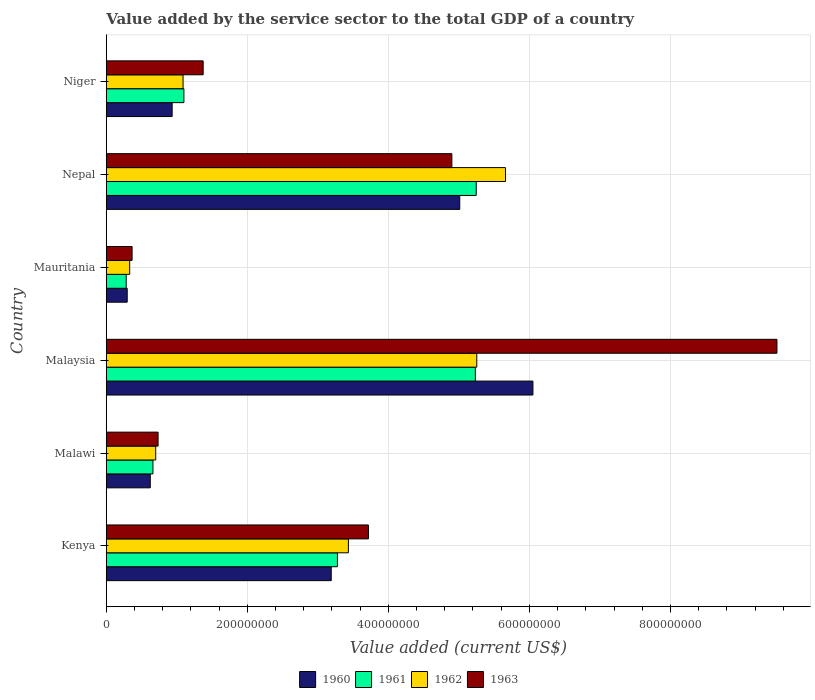How many different coloured bars are there?
Your answer should be compact. 4. How many bars are there on the 6th tick from the bottom?
Your answer should be very brief. 4. What is the label of the 6th group of bars from the top?
Ensure brevity in your answer.  Kenya. In how many cases, is the number of bars for a given country not equal to the number of legend labels?
Offer a terse response. 0. What is the value added by the service sector to the total GDP in 1961 in Nepal?
Provide a succinct answer. 5.25e+08. Across all countries, what is the maximum value added by the service sector to the total GDP in 1961?
Keep it short and to the point. 5.25e+08. Across all countries, what is the minimum value added by the service sector to the total GDP in 1960?
Your answer should be compact. 2.97e+07. In which country was the value added by the service sector to the total GDP in 1961 maximum?
Make the answer very short. Nepal. In which country was the value added by the service sector to the total GDP in 1960 minimum?
Your response must be concise. Mauritania. What is the total value added by the service sector to the total GDP in 1960 in the graph?
Give a very brief answer. 1.61e+09. What is the difference between the value added by the service sector to the total GDP in 1960 in Kenya and that in Nepal?
Make the answer very short. -1.82e+08. What is the difference between the value added by the service sector to the total GDP in 1960 in Malaysia and the value added by the service sector to the total GDP in 1962 in Niger?
Keep it short and to the point. 4.96e+08. What is the average value added by the service sector to the total GDP in 1962 per country?
Your answer should be very brief. 2.75e+08. What is the difference between the value added by the service sector to the total GDP in 1960 and value added by the service sector to the total GDP in 1962 in Kenya?
Ensure brevity in your answer.  -2.43e+07. What is the ratio of the value added by the service sector to the total GDP in 1962 in Kenya to that in Malaysia?
Your response must be concise. 0.65. Is the value added by the service sector to the total GDP in 1963 in Nepal less than that in Niger?
Keep it short and to the point. No. Is the difference between the value added by the service sector to the total GDP in 1960 in Kenya and Nepal greater than the difference between the value added by the service sector to the total GDP in 1962 in Kenya and Nepal?
Provide a succinct answer. Yes. What is the difference between the highest and the second highest value added by the service sector to the total GDP in 1963?
Keep it short and to the point. 4.61e+08. What is the difference between the highest and the lowest value added by the service sector to the total GDP in 1962?
Give a very brief answer. 5.33e+08. What does the 4th bar from the top in Niger represents?
Keep it short and to the point. 1960. What does the 4th bar from the bottom in Malawi represents?
Your answer should be very brief. 1963. Are all the bars in the graph horizontal?
Give a very brief answer. Yes. How many countries are there in the graph?
Your answer should be very brief. 6. What is the difference between two consecutive major ticks on the X-axis?
Offer a very short reply. 2.00e+08. Are the values on the major ticks of X-axis written in scientific E-notation?
Keep it short and to the point. No. Does the graph contain grids?
Offer a terse response. Yes. How are the legend labels stacked?
Keep it short and to the point. Horizontal. What is the title of the graph?
Provide a short and direct response. Value added by the service sector to the total GDP of a country. Does "2011" appear as one of the legend labels in the graph?
Your response must be concise. No. What is the label or title of the X-axis?
Provide a succinct answer. Value added (current US$). What is the Value added (current US$) of 1960 in Kenya?
Make the answer very short. 3.19e+08. What is the Value added (current US$) of 1961 in Kenya?
Offer a terse response. 3.28e+08. What is the Value added (current US$) in 1962 in Kenya?
Ensure brevity in your answer.  3.43e+08. What is the Value added (current US$) in 1963 in Kenya?
Your response must be concise. 3.72e+08. What is the Value added (current US$) in 1960 in Malawi?
Offer a very short reply. 6.24e+07. What is the Value added (current US$) of 1961 in Malawi?
Ensure brevity in your answer.  6.62e+07. What is the Value added (current US$) in 1962 in Malawi?
Your answer should be very brief. 7.01e+07. What is the Value added (current US$) in 1963 in Malawi?
Keep it short and to the point. 7.35e+07. What is the Value added (current US$) of 1960 in Malaysia?
Ensure brevity in your answer.  6.05e+08. What is the Value added (current US$) of 1961 in Malaysia?
Offer a terse response. 5.23e+08. What is the Value added (current US$) in 1962 in Malaysia?
Your answer should be very brief. 5.25e+08. What is the Value added (current US$) of 1963 in Malaysia?
Make the answer very short. 9.51e+08. What is the Value added (current US$) of 1960 in Mauritania?
Your response must be concise. 2.97e+07. What is the Value added (current US$) in 1961 in Mauritania?
Your answer should be compact. 2.83e+07. What is the Value added (current US$) in 1962 in Mauritania?
Provide a succinct answer. 3.32e+07. What is the Value added (current US$) of 1963 in Mauritania?
Make the answer very short. 3.67e+07. What is the Value added (current US$) in 1960 in Nepal?
Your response must be concise. 5.01e+08. What is the Value added (current US$) in 1961 in Nepal?
Provide a succinct answer. 5.25e+08. What is the Value added (current US$) of 1962 in Nepal?
Give a very brief answer. 5.66e+08. What is the Value added (current US$) in 1963 in Nepal?
Your answer should be compact. 4.90e+08. What is the Value added (current US$) in 1960 in Niger?
Provide a short and direct response. 9.35e+07. What is the Value added (current US$) in 1961 in Niger?
Your response must be concise. 1.10e+08. What is the Value added (current US$) in 1962 in Niger?
Offer a terse response. 1.09e+08. What is the Value added (current US$) of 1963 in Niger?
Offer a terse response. 1.37e+08. Across all countries, what is the maximum Value added (current US$) in 1960?
Ensure brevity in your answer.  6.05e+08. Across all countries, what is the maximum Value added (current US$) of 1961?
Your answer should be very brief. 5.25e+08. Across all countries, what is the maximum Value added (current US$) of 1962?
Your answer should be compact. 5.66e+08. Across all countries, what is the maximum Value added (current US$) of 1963?
Give a very brief answer. 9.51e+08. Across all countries, what is the minimum Value added (current US$) in 1960?
Your answer should be very brief. 2.97e+07. Across all countries, what is the minimum Value added (current US$) of 1961?
Offer a very short reply. 2.83e+07. Across all countries, what is the minimum Value added (current US$) of 1962?
Your answer should be compact. 3.32e+07. Across all countries, what is the minimum Value added (current US$) of 1963?
Ensure brevity in your answer.  3.67e+07. What is the total Value added (current US$) in 1960 in the graph?
Make the answer very short. 1.61e+09. What is the total Value added (current US$) in 1961 in the graph?
Offer a very short reply. 1.58e+09. What is the total Value added (current US$) of 1962 in the graph?
Offer a very short reply. 1.65e+09. What is the total Value added (current US$) of 1963 in the graph?
Your response must be concise. 2.06e+09. What is the difference between the Value added (current US$) of 1960 in Kenya and that in Malawi?
Your answer should be very brief. 2.57e+08. What is the difference between the Value added (current US$) in 1961 in Kenya and that in Malawi?
Give a very brief answer. 2.62e+08. What is the difference between the Value added (current US$) in 1962 in Kenya and that in Malawi?
Your answer should be compact. 2.73e+08. What is the difference between the Value added (current US$) in 1963 in Kenya and that in Malawi?
Ensure brevity in your answer.  2.98e+08. What is the difference between the Value added (current US$) in 1960 in Kenya and that in Malaysia?
Provide a short and direct response. -2.86e+08. What is the difference between the Value added (current US$) of 1961 in Kenya and that in Malaysia?
Offer a very short reply. -1.96e+08. What is the difference between the Value added (current US$) of 1962 in Kenya and that in Malaysia?
Provide a short and direct response. -1.82e+08. What is the difference between the Value added (current US$) in 1963 in Kenya and that in Malaysia?
Give a very brief answer. -5.79e+08. What is the difference between the Value added (current US$) of 1960 in Kenya and that in Mauritania?
Offer a terse response. 2.89e+08. What is the difference between the Value added (current US$) of 1961 in Kenya and that in Mauritania?
Give a very brief answer. 3.00e+08. What is the difference between the Value added (current US$) in 1962 in Kenya and that in Mauritania?
Offer a terse response. 3.10e+08. What is the difference between the Value added (current US$) in 1963 in Kenya and that in Mauritania?
Ensure brevity in your answer.  3.35e+08. What is the difference between the Value added (current US$) of 1960 in Kenya and that in Nepal?
Keep it short and to the point. -1.82e+08. What is the difference between the Value added (current US$) of 1961 in Kenya and that in Nepal?
Your answer should be very brief. -1.97e+08. What is the difference between the Value added (current US$) in 1962 in Kenya and that in Nepal?
Your answer should be very brief. -2.23e+08. What is the difference between the Value added (current US$) of 1963 in Kenya and that in Nepal?
Your answer should be very brief. -1.18e+08. What is the difference between the Value added (current US$) of 1960 in Kenya and that in Niger?
Keep it short and to the point. 2.26e+08. What is the difference between the Value added (current US$) of 1961 in Kenya and that in Niger?
Keep it short and to the point. 2.18e+08. What is the difference between the Value added (current US$) in 1962 in Kenya and that in Niger?
Keep it short and to the point. 2.34e+08. What is the difference between the Value added (current US$) in 1963 in Kenya and that in Niger?
Provide a short and direct response. 2.34e+08. What is the difference between the Value added (current US$) of 1960 in Malawi and that in Malaysia?
Keep it short and to the point. -5.43e+08. What is the difference between the Value added (current US$) of 1961 in Malawi and that in Malaysia?
Provide a succinct answer. -4.57e+08. What is the difference between the Value added (current US$) in 1962 in Malawi and that in Malaysia?
Give a very brief answer. -4.55e+08. What is the difference between the Value added (current US$) in 1963 in Malawi and that in Malaysia?
Provide a succinct answer. -8.78e+08. What is the difference between the Value added (current US$) in 1960 in Malawi and that in Mauritania?
Make the answer very short. 3.27e+07. What is the difference between the Value added (current US$) of 1961 in Malawi and that in Mauritania?
Offer a terse response. 3.79e+07. What is the difference between the Value added (current US$) of 1962 in Malawi and that in Mauritania?
Provide a succinct answer. 3.69e+07. What is the difference between the Value added (current US$) in 1963 in Malawi and that in Mauritania?
Ensure brevity in your answer.  3.68e+07. What is the difference between the Value added (current US$) in 1960 in Malawi and that in Nepal?
Ensure brevity in your answer.  -4.39e+08. What is the difference between the Value added (current US$) in 1961 in Malawi and that in Nepal?
Provide a succinct answer. -4.58e+08. What is the difference between the Value added (current US$) in 1962 in Malawi and that in Nepal?
Your answer should be compact. -4.96e+08. What is the difference between the Value added (current US$) in 1963 in Malawi and that in Nepal?
Make the answer very short. -4.17e+08. What is the difference between the Value added (current US$) in 1960 in Malawi and that in Niger?
Your answer should be compact. -3.10e+07. What is the difference between the Value added (current US$) of 1961 in Malawi and that in Niger?
Your response must be concise. -4.39e+07. What is the difference between the Value added (current US$) in 1962 in Malawi and that in Niger?
Keep it short and to the point. -3.88e+07. What is the difference between the Value added (current US$) in 1963 in Malawi and that in Niger?
Your answer should be very brief. -6.39e+07. What is the difference between the Value added (current US$) of 1960 in Malaysia and that in Mauritania?
Make the answer very short. 5.75e+08. What is the difference between the Value added (current US$) in 1961 in Malaysia and that in Mauritania?
Make the answer very short. 4.95e+08. What is the difference between the Value added (current US$) of 1962 in Malaysia and that in Mauritania?
Provide a succinct answer. 4.92e+08. What is the difference between the Value added (current US$) of 1963 in Malaysia and that in Mauritania?
Ensure brevity in your answer.  9.14e+08. What is the difference between the Value added (current US$) of 1960 in Malaysia and that in Nepal?
Offer a very short reply. 1.04e+08. What is the difference between the Value added (current US$) in 1961 in Malaysia and that in Nepal?
Offer a very short reply. -1.26e+06. What is the difference between the Value added (current US$) in 1962 in Malaysia and that in Nepal?
Your answer should be compact. -4.07e+07. What is the difference between the Value added (current US$) in 1963 in Malaysia and that in Nepal?
Keep it short and to the point. 4.61e+08. What is the difference between the Value added (current US$) in 1960 in Malaysia and that in Niger?
Your answer should be very brief. 5.12e+08. What is the difference between the Value added (current US$) in 1961 in Malaysia and that in Niger?
Offer a terse response. 4.13e+08. What is the difference between the Value added (current US$) in 1962 in Malaysia and that in Niger?
Provide a short and direct response. 4.16e+08. What is the difference between the Value added (current US$) in 1963 in Malaysia and that in Niger?
Offer a terse response. 8.14e+08. What is the difference between the Value added (current US$) of 1960 in Mauritania and that in Nepal?
Your answer should be very brief. -4.72e+08. What is the difference between the Value added (current US$) of 1961 in Mauritania and that in Nepal?
Ensure brevity in your answer.  -4.96e+08. What is the difference between the Value added (current US$) in 1962 in Mauritania and that in Nepal?
Keep it short and to the point. -5.33e+08. What is the difference between the Value added (current US$) of 1963 in Mauritania and that in Nepal?
Offer a very short reply. -4.53e+08. What is the difference between the Value added (current US$) in 1960 in Mauritania and that in Niger?
Keep it short and to the point. -6.37e+07. What is the difference between the Value added (current US$) of 1961 in Mauritania and that in Niger?
Ensure brevity in your answer.  -8.18e+07. What is the difference between the Value added (current US$) in 1962 in Mauritania and that in Niger?
Your response must be concise. -7.57e+07. What is the difference between the Value added (current US$) in 1963 in Mauritania and that in Niger?
Offer a terse response. -1.01e+08. What is the difference between the Value added (current US$) in 1960 in Nepal and that in Niger?
Make the answer very short. 4.08e+08. What is the difference between the Value added (current US$) of 1961 in Nepal and that in Niger?
Your answer should be compact. 4.14e+08. What is the difference between the Value added (current US$) of 1962 in Nepal and that in Niger?
Provide a succinct answer. 4.57e+08. What is the difference between the Value added (current US$) in 1963 in Nepal and that in Niger?
Offer a very short reply. 3.53e+08. What is the difference between the Value added (current US$) of 1960 in Kenya and the Value added (current US$) of 1961 in Malawi?
Provide a succinct answer. 2.53e+08. What is the difference between the Value added (current US$) of 1960 in Kenya and the Value added (current US$) of 1962 in Malawi?
Offer a very short reply. 2.49e+08. What is the difference between the Value added (current US$) of 1960 in Kenya and the Value added (current US$) of 1963 in Malawi?
Offer a very short reply. 2.46e+08. What is the difference between the Value added (current US$) of 1961 in Kenya and the Value added (current US$) of 1962 in Malawi?
Provide a succinct answer. 2.58e+08. What is the difference between the Value added (current US$) of 1961 in Kenya and the Value added (current US$) of 1963 in Malawi?
Your answer should be very brief. 2.54e+08. What is the difference between the Value added (current US$) of 1962 in Kenya and the Value added (current US$) of 1963 in Malawi?
Offer a very short reply. 2.70e+08. What is the difference between the Value added (current US$) in 1960 in Kenya and the Value added (current US$) in 1961 in Malaysia?
Ensure brevity in your answer.  -2.04e+08. What is the difference between the Value added (current US$) of 1960 in Kenya and the Value added (current US$) of 1962 in Malaysia?
Offer a terse response. -2.06e+08. What is the difference between the Value added (current US$) in 1960 in Kenya and the Value added (current US$) in 1963 in Malaysia?
Keep it short and to the point. -6.32e+08. What is the difference between the Value added (current US$) in 1961 in Kenya and the Value added (current US$) in 1962 in Malaysia?
Keep it short and to the point. -1.98e+08. What is the difference between the Value added (current US$) of 1961 in Kenya and the Value added (current US$) of 1963 in Malaysia?
Your answer should be very brief. -6.23e+08. What is the difference between the Value added (current US$) of 1962 in Kenya and the Value added (current US$) of 1963 in Malaysia?
Offer a very short reply. -6.08e+08. What is the difference between the Value added (current US$) in 1960 in Kenya and the Value added (current US$) in 1961 in Mauritania?
Your answer should be very brief. 2.91e+08. What is the difference between the Value added (current US$) in 1960 in Kenya and the Value added (current US$) in 1962 in Mauritania?
Make the answer very short. 2.86e+08. What is the difference between the Value added (current US$) in 1960 in Kenya and the Value added (current US$) in 1963 in Mauritania?
Give a very brief answer. 2.82e+08. What is the difference between the Value added (current US$) of 1961 in Kenya and the Value added (current US$) of 1962 in Mauritania?
Provide a succinct answer. 2.95e+08. What is the difference between the Value added (current US$) in 1961 in Kenya and the Value added (current US$) in 1963 in Mauritania?
Give a very brief answer. 2.91e+08. What is the difference between the Value added (current US$) in 1962 in Kenya and the Value added (current US$) in 1963 in Mauritania?
Offer a very short reply. 3.07e+08. What is the difference between the Value added (current US$) in 1960 in Kenya and the Value added (current US$) in 1961 in Nepal?
Keep it short and to the point. -2.06e+08. What is the difference between the Value added (current US$) in 1960 in Kenya and the Value added (current US$) in 1962 in Nepal?
Ensure brevity in your answer.  -2.47e+08. What is the difference between the Value added (current US$) of 1960 in Kenya and the Value added (current US$) of 1963 in Nepal?
Offer a very short reply. -1.71e+08. What is the difference between the Value added (current US$) of 1961 in Kenya and the Value added (current US$) of 1962 in Nepal?
Give a very brief answer. -2.38e+08. What is the difference between the Value added (current US$) in 1961 in Kenya and the Value added (current US$) in 1963 in Nepal?
Your answer should be very brief. -1.62e+08. What is the difference between the Value added (current US$) in 1962 in Kenya and the Value added (current US$) in 1963 in Nepal?
Offer a very short reply. -1.47e+08. What is the difference between the Value added (current US$) of 1960 in Kenya and the Value added (current US$) of 1961 in Niger?
Provide a succinct answer. 2.09e+08. What is the difference between the Value added (current US$) in 1960 in Kenya and the Value added (current US$) in 1962 in Niger?
Your answer should be compact. 2.10e+08. What is the difference between the Value added (current US$) in 1960 in Kenya and the Value added (current US$) in 1963 in Niger?
Your answer should be compact. 1.82e+08. What is the difference between the Value added (current US$) of 1961 in Kenya and the Value added (current US$) of 1962 in Niger?
Offer a very short reply. 2.19e+08. What is the difference between the Value added (current US$) in 1961 in Kenya and the Value added (current US$) in 1963 in Niger?
Give a very brief answer. 1.90e+08. What is the difference between the Value added (current US$) in 1962 in Kenya and the Value added (current US$) in 1963 in Niger?
Provide a short and direct response. 2.06e+08. What is the difference between the Value added (current US$) of 1960 in Malawi and the Value added (current US$) of 1961 in Malaysia?
Provide a short and direct response. -4.61e+08. What is the difference between the Value added (current US$) of 1960 in Malawi and the Value added (current US$) of 1962 in Malaysia?
Give a very brief answer. -4.63e+08. What is the difference between the Value added (current US$) of 1960 in Malawi and the Value added (current US$) of 1963 in Malaysia?
Offer a very short reply. -8.89e+08. What is the difference between the Value added (current US$) of 1961 in Malawi and the Value added (current US$) of 1962 in Malaysia?
Offer a terse response. -4.59e+08. What is the difference between the Value added (current US$) of 1961 in Malawi and the Value added (current US$) of 1963 in Malaysia?
Your answer should be compact. -8.85e+08. What is the difference between the Value added (current US$) of 1962 in Malawi and the Value added (current US$) of 1963 in Malaysia?
Provide a succinct answer. -8.81e+08. What is the difference between the Value added (current US$) of 1960 in Malawi and the Value added (current US$) of 1961 in Mauritania?
Your answer should be compact. 3.41e+07. What is the difference between the Value added (current US$) of 1960 in Malawi and the Value added (current US$) of 1962 in Mauritania?
Your response must be concise. 2.92e+07. What is the difference between the Value added (current US$) of 1960 in Malawi and the Value added (current US$) of 1963 in Mauritania?
Your answer should be very brief. 2.58e+07. What is the difference between the Value added (current US$) of 1961 in Malawi and the Value added (current US$) of 1962 in Mauritania?
Offer a terse response. 3.30e+07. What is the difference between the Value added (current US$) of 1961 in Malawi and the Value added (current US$) of 1963 in Mauritania?
Give a very brief answer. 2.96e+07. What is the difference between the Value added (current US$) of 1962 in Malawi and the Value added (current US$) of 1963 in Mauritania?
Ensure brevity in your answer.  3.35e+07. What is the difference between the Value added (current US$) of 1960 in Malawi and the Value added (current US$) of 1961 in Nepal?
Ensure brevity in your answer.  -4.62e+08. What is the difference between the Value added (current US$) in 1960 in Malawi and the Value added (current US$) in 1962 in Nepal?
Make the answer very short. -5.04e+08. What is the difference between the Value added (current US$) in 1960 in Malawi and the Value added (current US$) in 1963 in Nepal?
Ensure brevity in your answer.  -4.28e+08. What is the difference between the Value added (current US$) in 1961 in Malawi and the Value added (current US$) in 1962 in Nepal?
Your response must be concise. -5.00e+08. What is the difference between the Value added (current US$) in 1961 in Malawi and the Value added (current US$) in 1963 in Nepal?
Keep it short and to the point. -4.24e+08. What is the difference between the Value added (current US$) in 1962 in Malawi and the Value added (current US$) in 1963 in Nepal?
Give a very brief answer. -4.20e+08. What is the difference between the Value added (current US$) in 1960 in Malawi and the Value added (current US$) in 1961 in Niger?
Give a very brief answer. -4.77e+07. What is the difference between the Value added (current US$) of 1960 in Malawi and the Value added (current US$) of 1962 in Niger?
Offer a terse response. -4.65e+07. What is the difference between the Value added (current US$) of 1960 in Malawi and the Value added (current US$) of 1963 in Niger?
Ensure brevity in your answer.  -7.50e+07. What is the difference between the Value added (current US$) of 1961 in Malawi and the Value added (current US$) of 1962 in Niger?
Offer a very short reply. -4.27e+07. What is the difference between the Value added (current US$) of 1961 in Malawi and the Value added (current US$) of 1963 in Niger?
Give a very brief answer. -7.12e+07. What is the difference between the Value added (current US$) in 1962 in Malawi and the Value added (current US$) in 1963 in Niger?
Your response must be concise. -6.73e+07. What is the difference between the Value added (current US$) in 1960 in Malaysia and the Value added (current US$) in 1961 in Mauritania?
Make the answer very short. 5.77e+08. What is the difference between the Value added (current US$) in 1960 in Malaysia and the Value added (current US$) in 1962 in Mauritania?
Provide a succinct answer. 5.72e+08. What is the difference between the Value added (current US$) of 1960 in Malaysia and the Value added (current US$) of 1963 in Mauritania?
Give a very brief answer. 5.68e+08. What is the difference between the Value added (current US$) of 1961 in Malaysia and the Value added (current US$) of 1962 in Mauritania?
Ensure brevity in your answer.  4.90e+08. What is the difference between the Value added (current US$) of 1961 in Malaysia and the Value added (current US$) of 1963 in Mauritania?
Provide a short and direct response. 4.87e+08. What is the difference between the Value added (current US$) in 1962 in Malaysia and the Value added (current US$) in 1963 in Mauritania?
Make the answer very short. 4.89e+08. What is the difference between the Value added (current US$) of 1960 in Malaysia and the Value added (current US$) of 1961 in Nepal?
Your answer should be very brief. 8.04e+07. What is the difference between the Value added (current US$) of 1960 in Malaysia and the Value added (current US$) of 1962 in Nepal?
Your answer should be compact. 3.89e+07. What is the difference between the Value added (current US$) in 1960 in Malaysia and the Value added (current US$) in 1963 in Nepal?
Keep it short and to the point. 1.15e+08. What is the difference between the Value added (current US$) in 1961 in Malaysia and the Value added (current US$) in 1962 in Nepal?
Give a very brief answer. -4.27e+07. What is the difference between the Value added (current US$) in 1961 in Malaysia and the Value added (current US$) in 1963 in Nepal?
Ensure brevity in your answer.  3.33e+07. What is the difference between the Value added (current US$) in 1962 in Malaysia and the Value added (current US$) in 1963 in Nepal?
Provide a succinct answer. 3.53e+07. What is the difference between the Value added (current US$) of 1960 in Malaysia and the Value added (current US$) of 1961 in Niger?
Offer a very short reply. 4.95e+08. What is the difference between the Value added (current US$) in 1960 in Malaysia and the Value added (current US$) in 1962 in Niger?
Your answer should be very brief. 4.96e+08. What is the difference between the Value added (current US$) in 1960 in Malaysia and the Value added (current US$) in 1963 in Niger?
Offer a terse response. 4.68e+08. What is the difference between the Value added (current US$) in 1961 in Malaysia and the Value added (current US$) in 1962 in Niger?
Offer a very short reply. 4.14e+08. What is the difference between the Value added (current US$) in 1961 in Malaysia and the Value added (current US$) in 1963 in Niger?
Your response must be concise. 3.86e+08. What is the difference between the Value added (current US$) of 1962 in Malaysia and the Value added (current US$) of 1963 in Niger?
Your answer should be very brief. 3.88e+08. What is the difference between the Value added (current US$) of 1960 in Mauritania and the Value added (current US$) of 1961 in Nepal?
Offer a terse response. -4.95e+08. What is the difference between the Value added (current US$) in 1960 in Mauritania and the Value added (current US$) in 1962 in Nepal?
Ensure brevity in your answer.  -5.36e+08. What is the difference between the Value added (current US$) of 1960 in Mauritania and the Value added (current US$) of 1963 in Nepal?
Make the answer very short. -4.60e+08. What is the difference between the Value added (current US$) in 1961 in Mauritania and the Value added (current US$) in 1962 in Nepal?
Provide a short and direct response. -5.38e+08. What is the difference between the Value added (current US$) of 1961 in Mauritania and the Value added (current US$) of 1963 in Nepal?
Keep it short and to the point. -4.62e+08. What is the difference between the Value added (current US$) in 1962 in Mauritania and the Value added (current US$) in 1963 in Nepal?
Make the answer very short. -4.57e+08. What is the difference between the Value added (current US$) in 1960 in Mauritania and the Value added (current US$) in 1961 in Niger?
Your answer should be very brief. -8.04e+07. What is the difference between the Value added (current US$) of 1960 in Mauritania and the Value added (current US$) of 1962 in Niger?
Offer a terse response. -7.92e+07. What is the difference between the Value added (current US$) of 1960 in Mauritania and the Value added (current US$) of 1963 in Niger?
Provide a succinct answer. -1.08e+08. What is the difference between the Value added (current US$) of 1961 in Mauritania and the Value added (current US$) of 1962 in Niger?
Offer a terse response. -8.06e+07. What is the difference between the Value added (current US$) in 1961 in Mauritania and the Value added (current US$) in 1963 in Niger?
Make the answer very short. -1.09e+08. What is the difference between the Value added (current US$) of 1962 in Mauritania and the Value added (current US$) of 1963 in Niger?
Give a very brief answer. -1.04e+08. What is the difference between the Value added (current US$) of 1960 in Nepal and the Value added (current US$) of 1961 in Niger?
Your answer should be very brief. 3.91e+08. What is the difference between the Value added (current US$) of 1960 in Nepal and the Value added (current US$) of 1962 in Niger?
Provide a short and direct response. 3.92e+08. What is the difference between the Value added (current US$) in 1960 in Nepal and the Value added (current US$) in 1963 in Niger?
Offer a very short reply. 3.64e+08. What is the difference between the Value added (current US$) in 1961 in Nepal and the Value added (current US$) in 1962 in Niger?
Your response must be concise. 4.16e+08. What is the difference between the Value added (current US$) in 1961 in Nepal and the Value added (current US$) in 1963 in Niger?
Provide a short and direct response. 3.87e+08. What is the difference between the Value added (current US$) in 1962 in Nepal and the Value added (current US$) in 1963 in Niger?
Provide a short and direct response. 4.29e+08. What is the average Value added (current US$) in 1960 per country?
Keep it short and to the point. 2.68e+08. What is the average Value added (current US$) of 1961 per country?
Offer a very short reply. 2.63e+08. What is the average Value added (current US$) of 1962 per country?
Keep it short and to the point. 2.75e+08. What is the average Value added (current US$) of 1963 per country?
Keep it short and to the point. 3.43e+08. What is the difference between the Value added (current US$) of 1960 and Value added (current US$) of 1961 in Kenya?
Offer a very short reply. -8.81e+06. What is the difference between the Value added (current US$) of 1960 and Value added (current US$) of 1962 in Kenya?
Make the answer very short. -2.43e+07. What is the difference between the Value added (current US$) in 1960 and Value added (current US$) in 1963 in Kenya?
Offer a terse response. -5.28e+07. What is the difference between the Value added (current US$) of 1961 and Value added (current US$) of 1962 in Kenya?
Offer a terse response. -1.55e+07. What is the difference between the Value added (current US$) of 1961 and Value added (current US$) of 1963 in Kenya?
Provide a succinct answer. -4.40e+07. What is the difference between the Value added (current US$) of 1962 and Value added (current US$) of 1963 in Kenya?
Make the answer very short. -2.84e+07. What is the difference between the Value added (current US$) in 1960 and Value added (current US$) in 1961 in Malawi?
Provide a succinct answer. -3.78e+06. What is the difference between the Value added (current US$) in 1960 and Value added (current US$) in 1962 in Malawi?
Keep it short and to the point. -7.70e+06. What is the difference between the Value added (current US$) in 1960 and Value added (current US$) in 1963 in Malawi?
Your response must be concise. -1.11e+07. What is the difference between the Value added (current US$) in 1961 and Value added (current US$) in 1962 in Malawi?
Provide a short and direct response. -3.92e+06. What is the difference between the Value added (current US$) of 1961 and Value added (current US$) of 1963 in Malawi?
Give a very brief answer. -7.28e+06. What is the difference between the Value added (current US$) of 1962 and Value added (current US$) of 1963 in Malawi?
Provide a short and direct response. -3.36e+06. What is the difference between the Value added (current US$) of 1960 and Value added (current US$) of 1961 in Malaysia?
Your answer should be compact. 8.16e+07. What is the difference between the Value added (current US$) in 1960 and Value added (current US$) in 1962 in Malaysia?
Offer a very short reply. 7.96e+07. What is the difference between the Value added (current US$) in 1960 and Value added (current US$) in 1963 in Malaysia?
Your answer should be compact. -3.46e+08. What is the difference between the Value added (current US$) in 1961 and Value added (current US$) in 1962 in Malaysia?
Ensure brevity in your answer.  -2.03e+06. What is the difference between the Value added (current US$) in 1961 and Value added (current US$) in 1963 in Malaysia?
Offer a very short reply. -4.28e+08. What is the difference between the Value added (current US$) in 1962 and Value added (current US$) in 1963 in Malaysia?
Provide a short and direct response. -4.26e+08. What is the difference between the Value added (current US$) of 1960 and Value added (current US$) of 1961 in Mauritania?
Keep it short and to the point. 1.42e+06. What is the difference between the Value added (current US$) of 1960 and Value added (current US$) of 1962 in Mauritania?
Your response must be concise. -3.51e+06. What is the difference between the Value added (current US$) in 1960 and Value added (current US$) in 1963 in Mauritania?
Keep it short and to the point. -6.94e+06. What is the difference between the Value added (current US$) in 1961 and Value added (current US$) in 1962 in Mauritania?
Keep it short and to the point. -4.93e+06. What is the difference between the Value added (current US$) in 1961 and Value added (current US$) in 1963 in Mauritania?
Give a very brief answer. -8.35e+06. What is the difference between the Value added (current US$) of 1962 and Value added (current US$) of 1963 in Mauritania?
Provide a short and direct response. -3.42e+06. What is the difference between the Value added (current US$) in 1960 and Value added (current US$) in 1961 in Nepal?
Your response must be concise. -2.34e+07. What is the difference between the Value added (current US$) in 1960 and Value added (current US$) in 1962 in Nepal?
Make the answer very short. -6.48e+07. What is the difference between the Value added (current US$) of 1960 and Value added (current US$) of 1963 in Nepal?
Make the answer very short. 1.12e+07. What is the difference between the Value added (current US$) of 1961 and Value added (current US$) of 1962 in Nepal?
Give a very brief answer. -4.15e+07. What is the difference between the Value added (current US$) in 1961 and Value added (current US$) in 1963 in Nepal?
Your answer should be compact. 3.46e+07. What is the difference between the Value added (current US$) in 1962 and Value added (current US$) in 1963 in Nepal?
Make the answer very short. 7.60e+07. What is the difference between the Value added (current US$) in 1960 and Value added (current US$) in 1961 in Niger?
Make the answer very short. -1.67e+07. What is the difference between the Value added (current US$) in 1960 and Value added (current US$) in 1962 in Niger?
Your response must be concise. -1.55e+07. What is the difference between the Value added (current US$) in 1960 and Value added (current US$) in 1963 in Niger?
Make the answer very short. -4.40e+07. What is the difference between the Value added (current US$) in 1961 and Value added (current US$) in 1962 in Niger?
Give a very brief answer. 1.20e+06. What is the difference between the Value added (current US$) in 1961 and Value added (current US$) in 1963 in Niger?
Make the answer very short. -2.73e+07. What is the difference between the Value added (current US$) in 1962 and Value added (current US$) in 1963 in Niger?
Give a very brief answer. -2.85e+07. What is the ratio of the Value added (current US$) in 1960 in Kenya to that in Malawi?
Give a very brief answer. 5.11. What is the ratio of the Value added (current US$) of 1961 in Kenya to that in Malawi?
Offer a very short reply. 4.95. What is the ratio of the Value added (current US$) in 1962 in Kenya to that in Malawi?
Offer a terse response. 4.89. What is the ratio of the Value added (current US$) in 1963 in Kenya to that in Malawi?
Your answer should be compact. 5.06. What is the ratio of the Value added (current US$) in 1960 in Kenya to that in Malaysia?
Offer a terse response. 0.53. What is the ratio of the Value added (current US$) of 1961 in Kenya to that in Malaysia?
Make the answer very short. 0.63. What is the ratio of the Value added (current US$) in 1962 in Kenya to that in Malaysia?
Offer a very short reply. 0.65. What is the ratio of the Value added (current US$) in 1963 in Kenya to that in Malaysia?
Your answer should be compact. 0.39. What is the ratio of the Value added (current US$) of 1960 in Kenya to that in Mauritania?
Your response must be concise. 10.73. What is the ratio of the Value added (current US$) in 1961 in Kenya to that in Mauritania?
Offer a terse response. 11.58. What is the ratio of the Value added (current US$) of 1962 in Kenya to that in Mauritania?
Provide a succinct answer. 10.33. What is the ratio of the Value added (current US$) of 1963 in Kenya to that in Mauritania?
Keep it short and to the point. 10.14. What is the ratio of the Value added (current US$) of 1960 in Kenya to that in Nepal?
Offer a terse response. 0.64. What is the ratio of the Value added (current US$) in 1961 in Kenya to that in Nepal?
Offer a very short reply. 0.62. What is the ratio of the Value added (current US$) in 1962 in Kenya to that in Nepal?
Your response must be concise. 0.61. What is the ratio of the Value added (current US$) in 1963 in Kenya to that in Nepal?
Your answer should be very brief. 0.76. What is the ratio of the Value added (current US$) in 1960 in Kenya to that in Niger?
Give a very brief answer. 3.41. What is the ratio of the Value added (current US$) of 1961 in Kenya to that in Niger?
Your answer should be compact. 2.98. What is the ratio of the Value added (current US$) in 1962 in Kenya to that in Niger?
Provide a succinct answer. 3.15. What is the ratio of the Value added (current US$) of 1963 in Kenya to that in Niger?
Ensure brevity in your answer.  2.71. What is the ratio of the Value added (current US$) in 1960 in Malawi to that in Malaysia?
Ensure brevity in your answer.  0.1. What is the ratio of the Value added (current US$) in 1961 in Malawi to that in Malaysia?
Your answer should be very brief. 0.13. What is the ratio of the Value added (current US$) of 1962 in Malawi to that in Malaysia?
Provide a short and direct response. 0.13. What is the ratio of the Value added (current US$) of 1963 in Malawi to that in Malaysia?
Your response must be concise. 0.08. What is the ratio of the Value added (current US$) in 1960 in Malawi to that in Mauritania?
Make the answer very short. 2.1. What is the ratio of the Value added (current US$) in 1961 in Malawi to that in Mauritania?
Keep it short and to the point. 2.34. What is the ratio of the Value added (current US$) in 1962 in Malawi to that in Mauritania?
Ensure brevity in your answer.  2.11. What is the ratio of the Value added (current US$) of 1963 in Malawi to that in Mauritania?
Your answer should be very brief. 2.01. What is the ratio of the Value added (current US$) in 1960 in Malawi to that in Nepal?
Offer a terse response. 0.12. What is the ratio of the Value added (current US$) in 1961 in Malawi to that in Nepal?
Give a very brief answer. 0.13. What is the ratio of the Value added (current US$) in 1962 in Malawi to that in Nepal?
Keep it short and to the point. 0.12. What is the ratio of the Value added (current US$) in 1960 in Malawi to that in Niger?
Provide a short and direct response. 0.67. What is the ratio of the Value added (current US$) of 1961 in Malawi to that in Niger?
Make the answer very short. 0.6. What is the ratio of the Value added (current US$) in 1962 in Malawi to that in Niger?
Keep it short and to the point. 0.64. What is the ratio of the Value added (current US$) in 1963 in Malawi to that in Niger?
Make the answer very short. 0.53. What is the ratio of the Value added (current US$) in 1960 in Malaysia to that in Mauritania?
Offer a terse response. 20.36. What is the ratio of the Value added (current US$) in 1961 in Malaysia to that in Mauritania?
Make the answer very short. 18.49. What is the ratio of the Value added (current US$) of 1962 in Malaysia to that in Mauritania?
Offer a terse response. 15.81. What is the ratio of the Value added (current US$) in 1963 in Malaysia to that in Mauritania?
Give a very brief answer. 25.94. What is the ratio of the Value added (current US$) in 1960 in Malaysia to that in Nepal?
Provide a short and direct response. 1.21. What is the ratio of the Value added (current US$) in 1961 in Malaysia to that in Nepal?
Your response must be concise. 1. What is the ratio of the Value added (current US$) in 1962 in Malaysia to that in Nepal?
Keep it short and to the point. 0.93. What is the ratio of the Value added (current US$) of 1963 in Malaysia to that in Nepal?
Keep it short and to the point. 1.94. What is the ratio of the Value added (current US$) of 1960 in Malaysia to that in Niger?
Your answer should be compact. 6.47. What is the ratio of the Value added (current US$) of 1961 in Malaysia to that in Niger?
Keep it short and to the point. 4.75. What is the ratio of the Value added (current US$) of 1962 in Malaysia to that in Niger?
Your response must be concise. 4.82. What is the ratio of the Value added (current US$) of 1963 in Malaysia to that in Niger?
Offer a very short reply. 6.92. What is the ratio of the Value added (current US$) of 1960 in Mauritania to that in Nepal?
Your answer should be compact. 0.06. What is the ratio of the Value added (current US$) of 1961 in Mauritania to that in Nepal?
Provide a short and direct response. 0.05. What is the ratio of the Value added (current US$) in 1962 in Mauritania to that in Nepal?
Ensure brevity in your answer.  0.06. What is the ratio of the Value added (current US$) in 1963 in Mauritania to that in Nepal?
Keep it short and to the point. 0.07. What is the ratio of the Value added (current US$) in 1960 in Mauritania to that in Niger?
Offer a terse response. 0.32. What is the ratio of the Value added (current US$) of 1961 in Mauritania to that in Niger?
Your answer should be compact. 0.26. What is the ratio of the Value added (current US$) in 1962 in Mauritania to that in Niger?
Give a very brief answer. 0.31. What is the ratio of the Value added (current US$) of 1963 in Mauritania to that in Niger?
Provide a succinct answer. 0.27. What is the ratio of the Value added (current US$) of 1960 in Nepal to that in Niger?
Your response must be concise. 5.36. What is the ratio of the Value added (current US$) of 1961 in Nepal to that in Niger?
Provide a short and direct response. 4.76. What is the ratio of the Value added (current US$) of 1962 in Nepal to that in Niger?
Ensure brevity in your answer.  5.2. What is the ratio of the Value added (current US$) of 1963 in Nepal to that in Niger?
Make the answer very short. 3.57. What is the difference between the highest and the second highest Value added (current US$) of 1960?
Your answer should be compact. 1.04e+08. What is the difference between the highest and the second highest Value added (current US$) in 1961?
Provide a short and direct response. 1.26e+06. What is the difference between the highest and the second highest Value added (current US$) of 1962?
Provide a succinct answer. 4.07e+07. What is the difference between the highest and the second highest Value added (current US$) in 1963?
Make the answer very short. 4.61e+08. What is the difference between the highest and the lowest Value added (current US$) of 1960?
Make the answer very short. 5.75e+08. What is the difference between the highest and the lowest Value added (current US$) of 1961?
Offer a very short reply. 4.96e+08. What is the difference between the highest and the lowest Value added (current US$) of 1962?
Make the answer very short. 5.33e+08. What is the difference between the highest and the lowest Value added (current US$) of 1963?
Offer a terse response. 9.14e+08. 